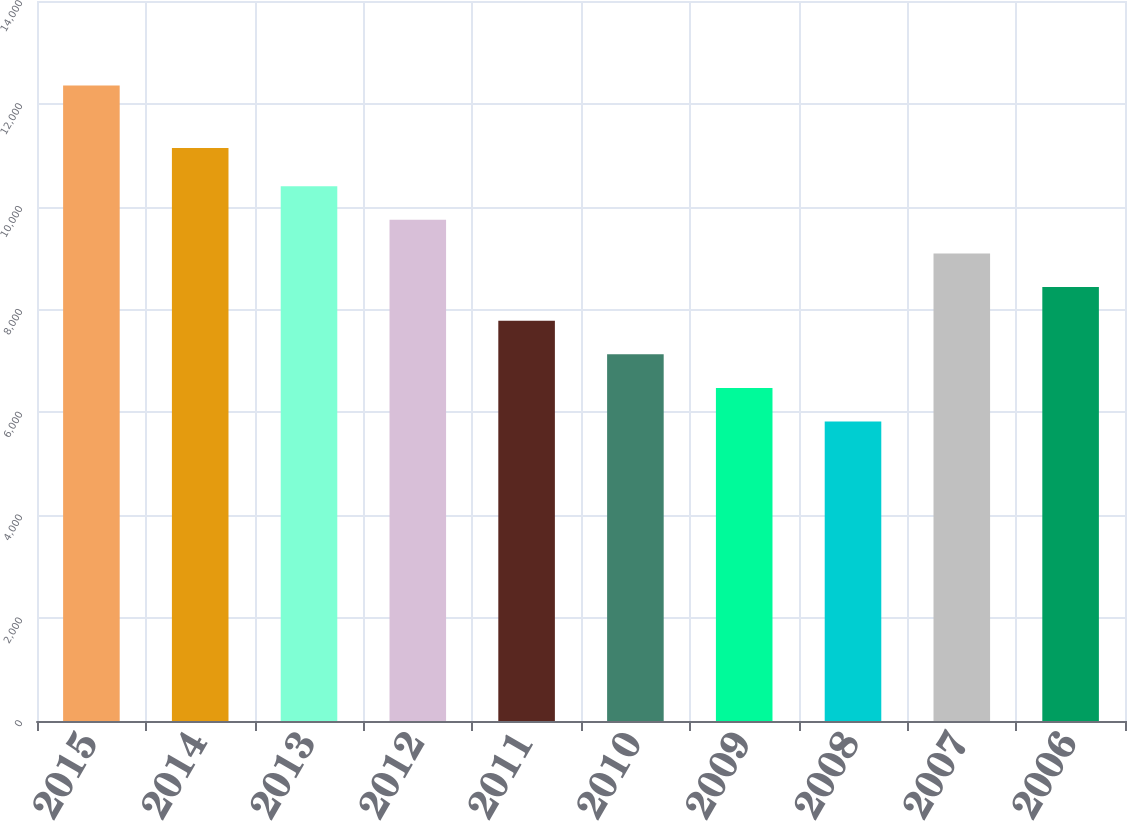Convert chart to OTSL. <chart><loc_0><loc_0><loc_500><loc_500><bar_chart><fcel>2015<fcel>2014<fcel>2013<fcel>2012<fcel>2011<fcel>2010<fcel>2009<fcel>2008<fcel>2007<fcel>2006<nl><fcel>12358<fcel>11141<fcel>10397.8<fcel>9744.4<fcel>7784.2<fcel>7130.8<fcel>6477.4<fcel>5824<fcel>9091<fcel>8437.6<nl></chart> 